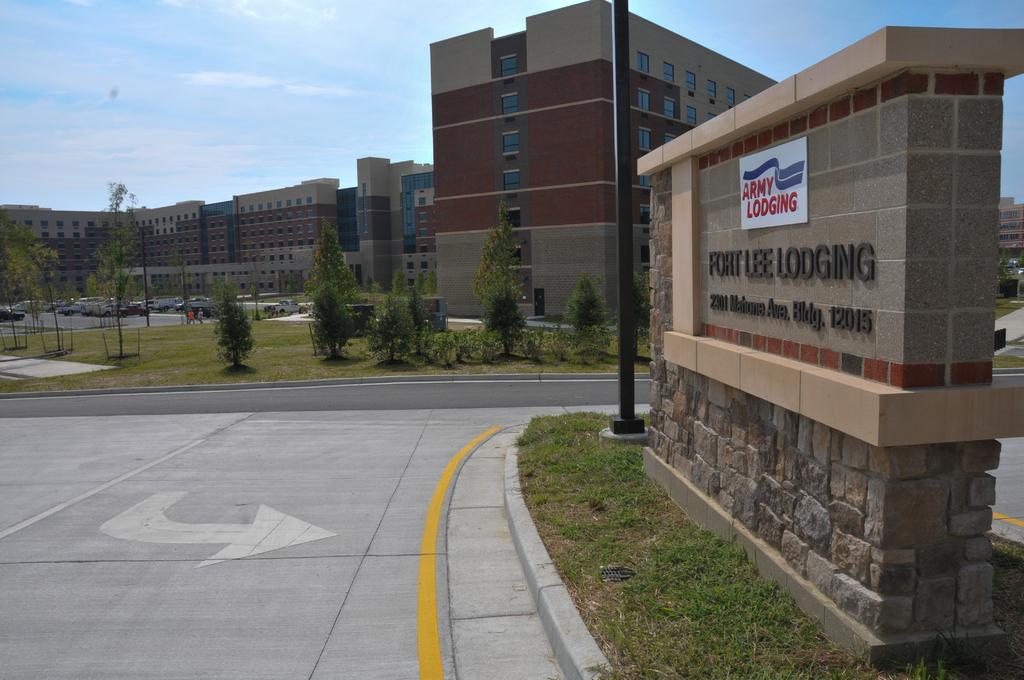Could you give a brief overview of what you see in this image? In the image we can see there are many buildings and windows of the buildings. There are many vehicles, there is a road, white and yellow lines on the road. This is a pole, grass, plant, trees, text and a cloudy sky. 